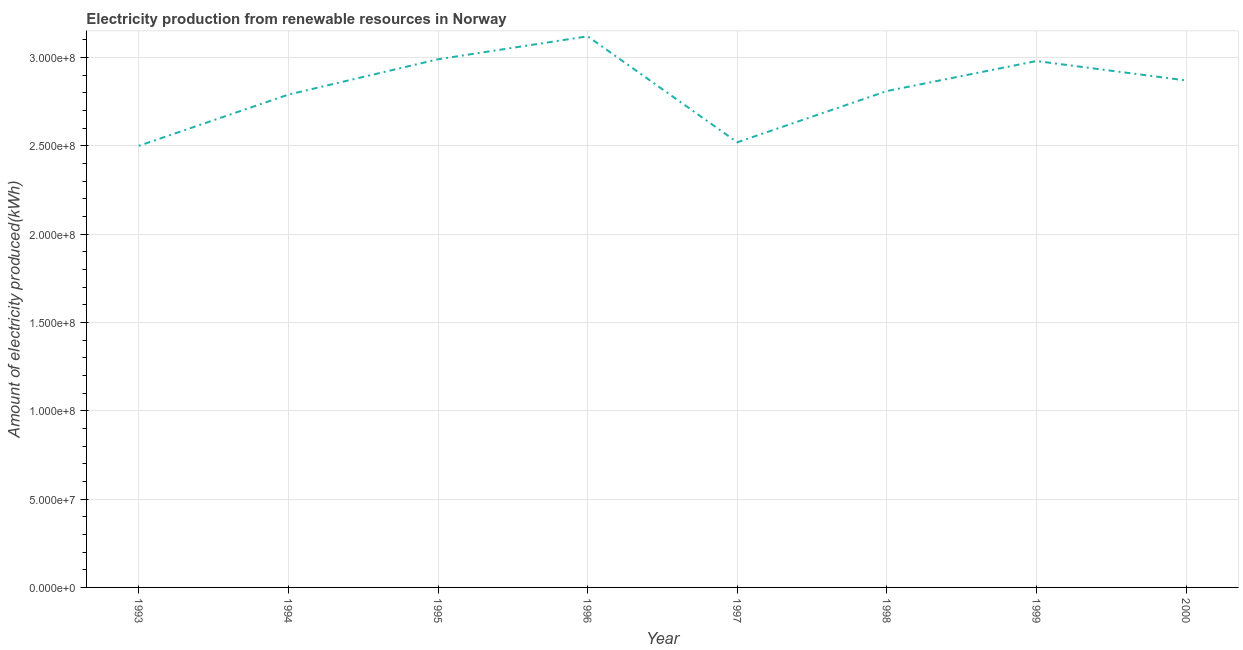What is the amount of electricity produced in 1996?
Provide a succinct answer. 3.12e+08. Across all years, what is the maximum amount of electricity produced?
Ensure brevity in your answer.  3.12e+08. Across all years, what is the minimum amount of electricity produced?
Ensure brevity in your answer.  2.50e+08. In which year was the amount of electricity produced maximum?
Your response must be concise. 1996. In which year was the amount of electricity produced minimum?
Give a very brief answer. 1993. What is the sum of the amount of electricity produced?
Offer a terse response. 2.26e+09. What is the difference between the amount of electricity produced in 1996 and 1998?
Keep it short and to the point. 3.10e+07. What is the average amount of electricity produced per year?
Your answer should be very brief. 2.82e+08. What is the median amount of electricity produced?
Offer a very short reply. 2.84e+08. In how many years, is the amount of electricity produced greater than 260000000 kWh?
Keep it short and to the point. 6. What is the ratio of the amount of electricity produced in 1994 to that in 1999?
Ensure brevity in your answer.  0.94. Is the amount of electricity produced in 1998 less than that in 2000?
Make the answer very short. Yes. Is the difference between the amount of electricity produced in 1993 and 1994 greater than the difference between any two years?
Provide a short and direct response. No. What is the difference between the highest and the second highest amount of electricity produced?
Give a very brief answer. 1.30e+07. What is the difference between the highest and the lowest amount of electricity produced?
Make the answer very short. 6.20e+07. In how many years, is the amount of electricity produced greater than the average amount of electricity produced taken over all years?
Your response must be concise. 4. Does the amount of electricity produced monotonically increase over the years?
Make the answer very short. No. Does the graph contain any zero values?
Keep it short and to the point. No. Does the graph contain grids?
Provide a short and direct response. Yes. What is the title of the graph?
Ensure brevity in your answer.  Electricity production from renewable resources in Norway. What is the label or title of the Y-axis?
Provide a short and direct response. Amount of electricity produced(kWh). What is the Amount of electricity produced(kWh) in 1993?
Provide a succinct answer. 2.50e+08. What is the Amount of electricity produced(kWh) of 1994?
Make the answer very short. 2.79e+08. What is the Amount of electricity produced(kWh) in 1995?
Your answer should be very brief. 2.99e+08. What is the Amount of electricity produced(kWh) of 1996?
Your answer should be very brief. 3.12e+08. What is the Amount of electricity produced(kWh) of 1997?
Your response must be concise. 2.52e+08. What is the Amount of electricity produced(kWh) in 1998?
Ensure brevity in your answer.  2.81e+08. What is the Amount of electricity produced(kWh) in 1999?
Offer a terse response. 2.98e+08. What is the Amount of electricity produced(kWh) of 2000?
Ensure brevity in your answer.  2.87e+08. What is the difference between the Amount of electricity produced(kWh) in 1993 and 1994?
Provide a succinct answer. -2.90e+07. What is the difference between the Amount of electricity produced(kWh) in 1993 and 1995?
Offer a very short reply. -4.90e+07. What is the difference between the Amount of electricity produced(kWh) in 1993 and 1996?
Ensure brevity in your answer.  -6.20e+07. What is the difference between the Amount of electricity produced(kWh) in 1993 and 1997?
Your response must be concise. -2.00e+06. What is the difference between the Amount of electricity produced(kWh) in 1993 and 1998?
Ensure brevity in your answer.  -3.10e+07. What is the difference between the Amount of electricity produced(kWh) in 1993 and 1999?
Offer a very short reply. -4.80e+07. What is the difference between the Amount of electricity produced(kWh) in 1993 and 2000?
Keep it short and to the point. -3.70e+07. What is the difference between the Amount of electricity produced(kWh) in 1994 and 1995?
Make the answer very short. -2.00e+07. What is the difference between the Amount of electricity produced(kWh) in 1994 and 1996?
Provide a succinct answer. -3.30e+07. What is the difference between the Amount of electricity produced(kWh) in 1994 and 1997?
Ensure brevity in your answer.  2.70e+07. What is the difference between the Amount of electricity produced(kWh) in 1994 and 1999?
Keep it short and to the point. -1.90e+07. What is the difference between the Amount of electricity produced(kWh) in 1994 and 2000?
Keep it short and to the point. -8.00e+06. What is the difference between the Amount of electricity produced(kWh) in 1995 and 1996?
Ensure brevity in your answer.  -1.30e+07. What is the difference between the Amount of electricity produced(kWh) in 1995 and 1997?
Ensure brevity in your answer.  4.70e+07. What is the difference between the Amount of electricity produced(kWh) in 1995 and 1998?
Provide a succinct answer. 1.80e+07. What is the difference between the Amount of electricity produced(kWh) in 1995 and 1999?
Your response must be concise. 1.00e+06. What is the difference between the Amount of electricity produced(kWh) in 1995 and 2000?
Provide a succinct answer. 1.20e+07. What is the difference between the Amount of electricity produced(kWh) in 1996 and 1997?
Your answer should be very brief. 6.00e+07. What is the difference between the Amount of electricity produced(kWh) in 1996 and 1998?
Offer a very short reply. 3.10e+07. What is the difference between the Amount of electricity produced(kWh) in 1996 and 1999?
Ensure brevity in your answer.  1.40e+07. What is the difference between the Amount of electricity produced(kWh) in 1996 and 2000?
Provide a short and direct response. 2.50e+07. What is the difference between the Amount of electricity produced(kWh) in 1997 and 1998?
Offer a very short reply. -2.90e+07. What is the difference between the Amount of electricity produced(kWh) in 1997 and 1999?
Keep it short and to the point. -4.60e+07. What is the difference between the Amount of electricity produced(kWh) in 1997 and 2000?
Offer a terse response. -3.50e+07. What is the difference between the Amount of electricity produced(kWh) in 1998 and 1999?
Your answer should be compact. -1.70e+07. What is the difference between the Amount of electricity produced(kWh) in 1998 and 2000?
Keep it short and to the point. -6.00e+06. What is the difference between the Amount of electricity produced(kWh) in 1999 and 2000?
Your response must be concise. 1.10e+07. What is the ratio of the Amount of electricity produced(kWh) in 1993 to that in 1994?
Offer a terse response. 0.9. What is the ratio of the Amount of electricity produced(kWh) in 1993 to that in 1995?
Give a very brief answer. 0.84. What is the ratio of the Amount of electricity produced(kWh) in 1993 to that in 1996?
Offer a very short reply. 0.8. What is the ratio of the Amount of electricity produced(kWh) in 1993 to that in 1997?
Your response must be concise. 0.99. What is the ratio of the Amount of electricity produced(kWh) in 1993 to that in 1998?
Make the answer very short. 0.89. What is the ratio of the Amount of electricity produced(kWh) in 1993 to that in 1999?
Provide a short and direct response. 0.84. What is the ratio of the Amount of electricity produced(kWh) in 1993 to that in 2000?
Your answer should be very brief. 0.87. What is the ratio of the Amount of electricity produced(kWh) in 1994 to that in 1995?
Your response must be concise. 0.93. What is the ratio of the Amount of electricity produced(kWh) in 1994 to that in 1996?
Provide a succinct answer. 0.89. What is the ratio of the Amount of electricity produced(kWh) in 1994 to that in 1997?
Provide a succinct answer. 1.11. What is the ratio of the Amount of electricity produced(kWh) in 1994 to that in 1998?
Ensure brevity in your answer.  0.99. What is the ratio of the Amount of electricity produced(kWh) in 1994 to that in 1999?
Offer a very short reply. 0.94. What is the ratio of the Amount of electricity produced(kWh) in 1995 to that in 1996?
Your answer should be very brief. 0.96. What is the ratio of the Amount of electricity produced(kWh) in 1995 to that in 1997?
Make the answer very short. 1.19. What is the ratio of the Amount of electricity produced(kWh) in 1995 to that in 1998?
Your answer should be compact. 1.06. What is the ratio of the Amount of electricity produced(kWh) in 1995 to that in 2000?
Offer a terse response. 1.04. What is the ratio of the Amount of electricity produced(kWh) in 1996 to that in 1997?
Keep it short and to the point. 1.24. What is the ratio of the Amount of electricity produced(kWh) in 1996 to that in 1998?
Your answer should be compact. 1.11. What is the ratio of the Amount of electricity produced(kWh) in 1996 to that in 1999?
Make the answer very short. 1.05. What is the ratio of the Amount of electricity produced(kWh) in 1996 to that in 2000?
Keep it short and to the point. 1.09. What is the ratio of the Amount of electricity produced(kWh) in 1997 to that in 1998?
Your answer should be very brief. 0.9. What is the ratio of the Amount of electricity produced(kWh) in 1997 to that in 1999?
Keep it short and to the point. 0.85. What is the ratio of the Amount of electricity produced(kWh) in 1997 to that in 2000?
Ensure brevity in your answer.  0.88. What is the ratio of the Amount of electricity produced(kWh) in 1998 to that in 1999?
Your answer should be very brief. 0.94. What is the ratio of the Amount of electricity produced(kWh) in 1998 to that in 2000?
Ensure brevity in your answer.  0.98. What is the ratio of the Amount of electricity produced(kWh) in 1999 to that in 2000?
Your response must be concise. 1.04. 